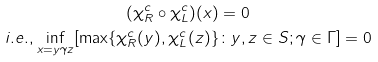<formula> <loc_0><loc_0><loc_500><loc_500>( \chi ^ { c } _ { R } \circ \chi ^ { c } _ { L } ) ( x ) & = 0 \\ i . e . , \underset { x = y \gamma z } { \inf } [ \max \{ \chi ^ { c } _ { R } ( y ) , \chi ^ { c } _ { L } ( z ) \} & \colon y , z \in S ; \gamma \in \Gamma ] = 0</formula> 